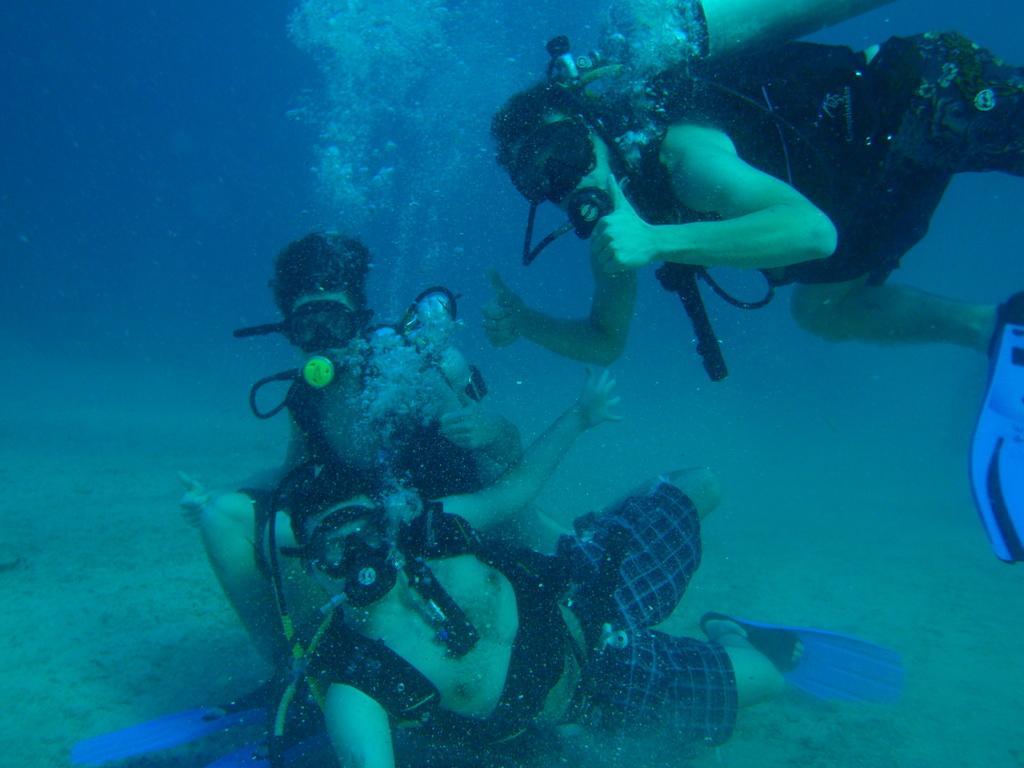In one or two sentences, can you explain what this image depicts? In this image we can see three persons swimming in the water. 